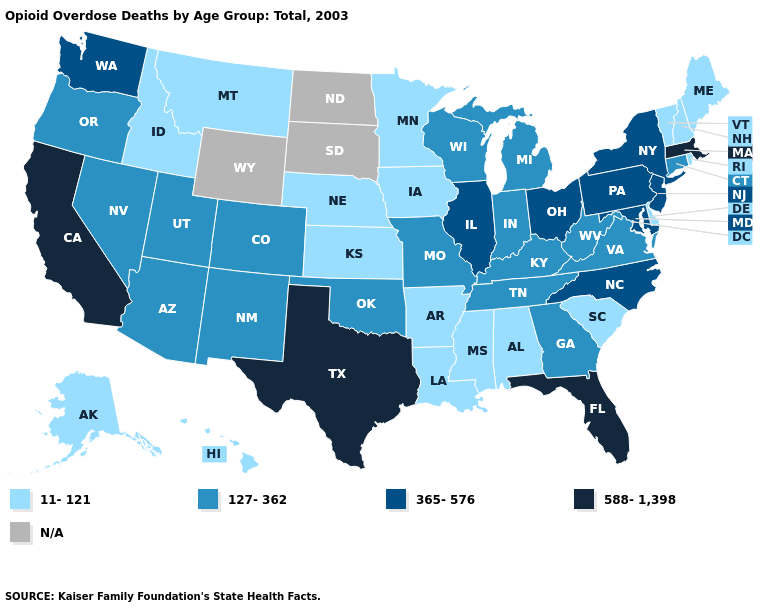How many symbols are there in the legend?
Give a very brief answer. 5. Among the states that border Alabama , does Mississippi have the lowest value?
Short answer required. Yes. What is the value of Michigan?
Give a very brief answer. 127-362. What is the lowest value in the USA?
Be succinct. 11-121. Does Iowa have the lowest value in the MidWest?
Keep it brief. Yes. What is the value of New York?
Be succinct. 365-576. Name the states that have a value in the range 11-121?
Quick response, please. Alabama, Alaska, Arkansas, Delaware, Hawaii, Idaho, Iowa, Kansas, Louisiana, Maine, Minnesota, Mississippi, Montana, Nebraska, New Hampshire, Rhode Island, South Carolina, Vermont. What is the value of North Dakota?
Give a very brief answer. N/A. Name the states that have a value in the range 11-121?
Short answer required. Alabama, Alaska, Arkansas, Delaware, Hawaii, Idaho, Iowa, Kansas, Louisiana, Maine, Minnesota, Mississippi, Montana, Nebraska, New Hampshire, Rhode Island, South Carolina, Vermont. Name the states that have a value in the range 11-121?
Give a very brief answer. Alabama, Alaska, Arkansas, Delaware, Hawaii, Idaho, Iowa, Kansas, Louisiana, Maine, Minnesota, Mississippi, Montana, Nebraska, New Hampshire, Rhode Island, South Carolina, Vermont. Does Alabama have the lowest value in the USA?
Give a very brief answer. Yes. 